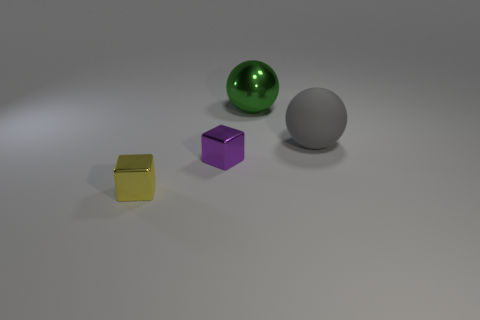Add 1 metallic spheres. How many objects exist? 5 Add 1 yellow metal things. How many yellow metal things are left? 2 Add 4 tiny gray blocks. How many tiny gray blocks exist? 4 Subtract 0 gray blocks. How many objects are left? 4 Subtract all blue rubber things. Subtract all large objects. How many objects are left? 2 